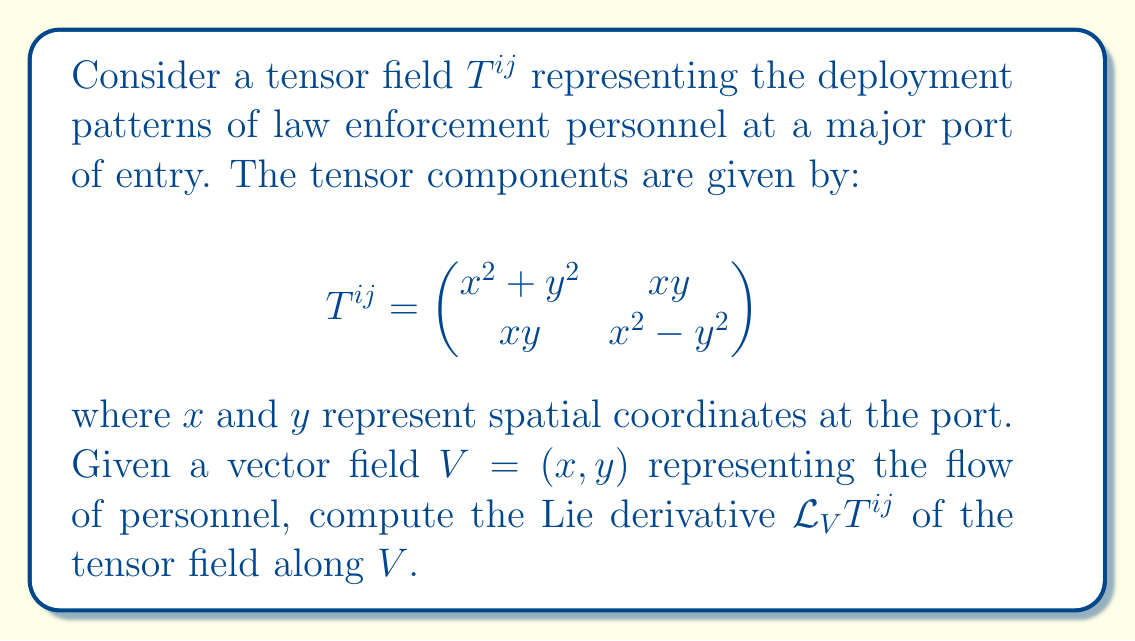Could you help me with this problem? To compute the Lie derivative of the tensor field $T^{ij}$ along the vector field $V$, we'll follow these steps:

1) The Lie derivative of a $(2,0)$ tensor field $T^{ij}$ along a vector field $V^k$ is given by:

   $$\mathcal{L}_V T^{ij} = V^k \partial_k T^{ij} - T^{kj} \partial_k V^i - T^{ik} \partial_k V^j$$

2) First, let's calculate $V^k \partial_k T^{ij}$:
   
   $\partial_x T^{11} = 2x, \partial_y T^{11} = 2y$
   $\partial_x T^{12} = y, \partial_y T^{12} = x$
   $\partial_x T^{21} = y, \partial_y T^{21} = x$
   $\partial_x T^{22} = 2x, \partial_y T^{22} = -2y$

   Therefore,
   $V^k \partial_k T^{11} = x(2x) + y(2y) = 2x^2 + 2y^2$
   $V^k \partial_k T^{12} = xy + yx = 2xy$
   $V^k \partial_k T^{21} = xy + yx = 2xy$
   $V^k \partial_k T^{22} = x(2x) + y(-2y) = 2x^2 - 2y^2$

3) Next, let's calculate $T^{kj} \partial_k V^i$:
   
   $\partial_x V^1 = 1, \partial_y V^1 = 0$
   $\partial_x V^2 = 0, \partial_y V^2 = 1$

   For $i=1$: $T^{kj} \partial_k V^1 = (x^2+y^2)(1) + xy(0) = x^2+y^2$
   For $i=2$: $T^{kj} \partial_k V^2 = xy(1) + (x^2-y^2)(1) = xy+x^2-y^2$

4) Similarly, let's calculate $T^{ik} \partial_k V^j$:

   For $j=1$: $T^{ik} \partial_k V^1 = (x^2+y^2)(1) + xy(0) = x^2+y^2$
   For $j=2$: $T^{ik} \partial_k V^2 = xy(1) + (x^2-y^2)(1) = xy+x^2-y^2$

5) Now, we can combine these results to get $\mathcal{L}_V T^{ij}$:

   $\mathcal{L}_V T^{11} = (2x^2 + 2y^2) - (x^2+y^2) - (x^2+y^2) = 0$
   $\mathcal{L}_V T^{12} = 2xy - (xy+x^2-y^2) - (x^2+y^2) = -2x^2+y^2$
   $\mathcal{L}_V T^{21} = 2xy - (x^2+y^2) - (xy+x^2-y^2) = y^2-2x^2$
   $\mathcal{L}_V T^{22} = (2x^2 - 2y^2) - (xy+x^2-y^2) - (xy+x^2-y^2) = 0$

Therefore, the Lie derivative of $T^{ij}$ along $V$ is:

$$\mathcal{L}_V T^{ij} = \begin{pmatrix}
0 & -2x^2+y^2 \\
y^2-2x^2 & 0
\end{pmatrix}$$
Answer: $$\mathcal{L}_V T^{ij} = \begin{pmatrix}
0 & -2x^2+y^2 \\
y^2-2x^2 & 0
\end{pmatrix}$$ 